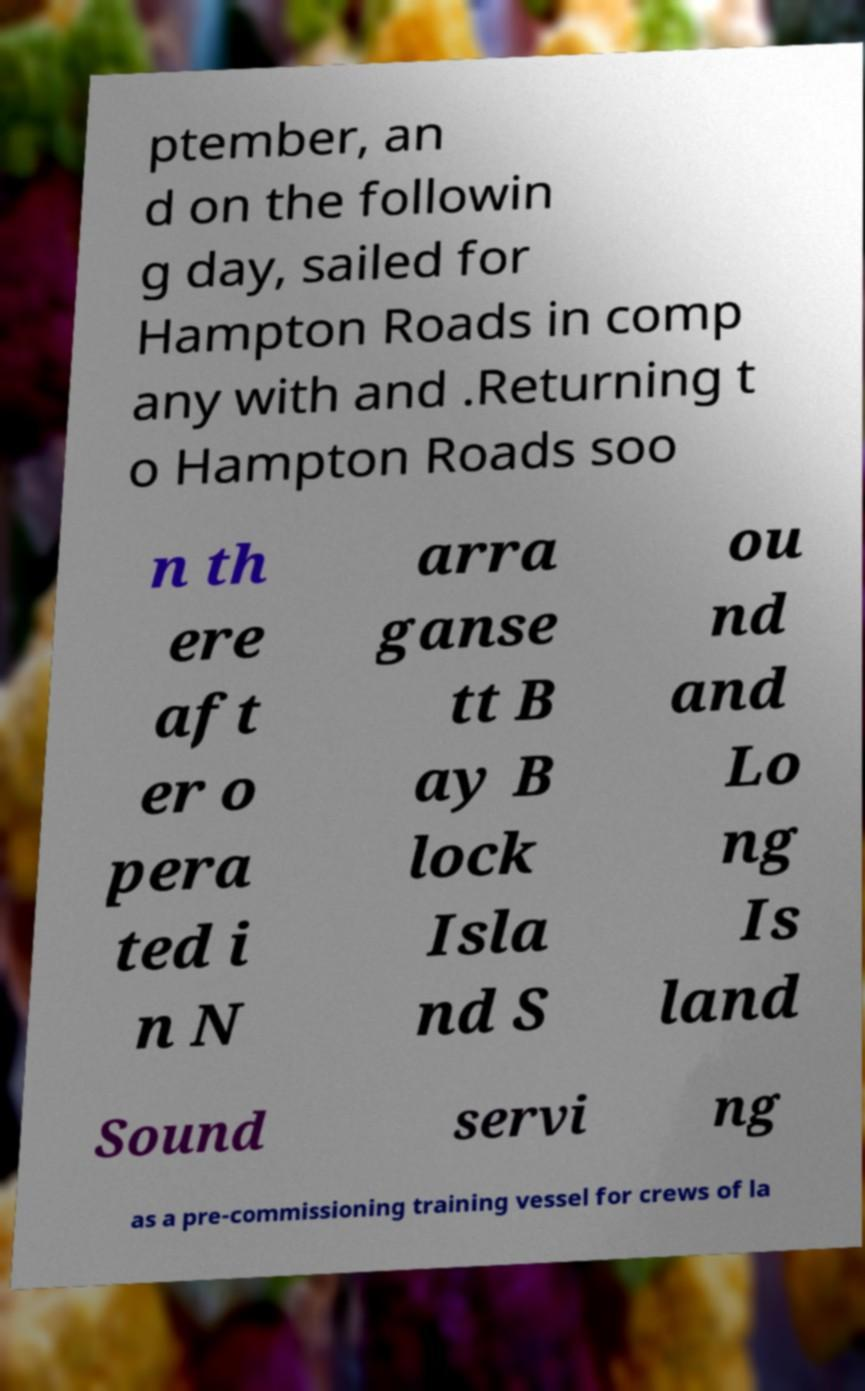Please read and relay the text visible in this image. What does it say? ptember, an d on the followin g day, sailed for Hampton Roads in comp any with and .Returning t o Hampton Roads soo n th ere aft er o pera ted i n N arra ganse tt B ay B lock Isla nd S ou nd and Lo ng Is land Sound servi ng as a pre-commissioning training vessel for crews of la 